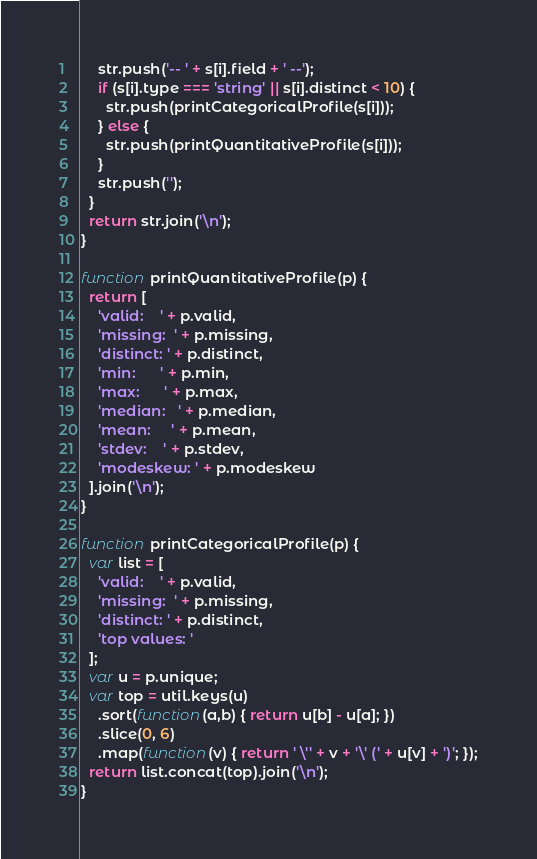<code> <loc_0><loc_0><loc_500><loc_500><_JavaScript_>    str.push('-- ' + s[i].field + ' --');
    if (s[i].type === 'string' || s[i].distinct < 10) {
      str.push(printCategoricalProfile(s[i]));
    } else {
      str.push(printQuantitativeProfile(s[i]));
    }
    str.push('');
  }
  return str.join('\n');
}

function printQuantitativeProfile(p) {
  return [
    'valid:    ' + p.valid,
    'missing:  ' + p.missing,
    'distinct: ' + p.distinct,
    'min:      ' + p.min,
    'max:      ' + p.max,
    'median:   ' + p.median,
    'mean:     ' + p.mean,
    'stdev:    ' + p.stdev,
    'modeskew: ' + p.modeskew
  ].join('\n');
}

function printCategoricalProfile(p) {
  var list = [
    'valid:    ' + p.valid,
    'missing:  ' + p.missing,
    'distinct: ' + p.distinct,
    'top values: '
  ];
  var u = p.unique;
  var top = util.keys(u)
    .sort(function(a,b) { return u[b] - u[a]; })
    .slice(0, 6)
    .map(function(v) { return ' \'' + v + '\' (' + u[v] + ')'; });
  return list.concat(top).join('\n');
}</code> 